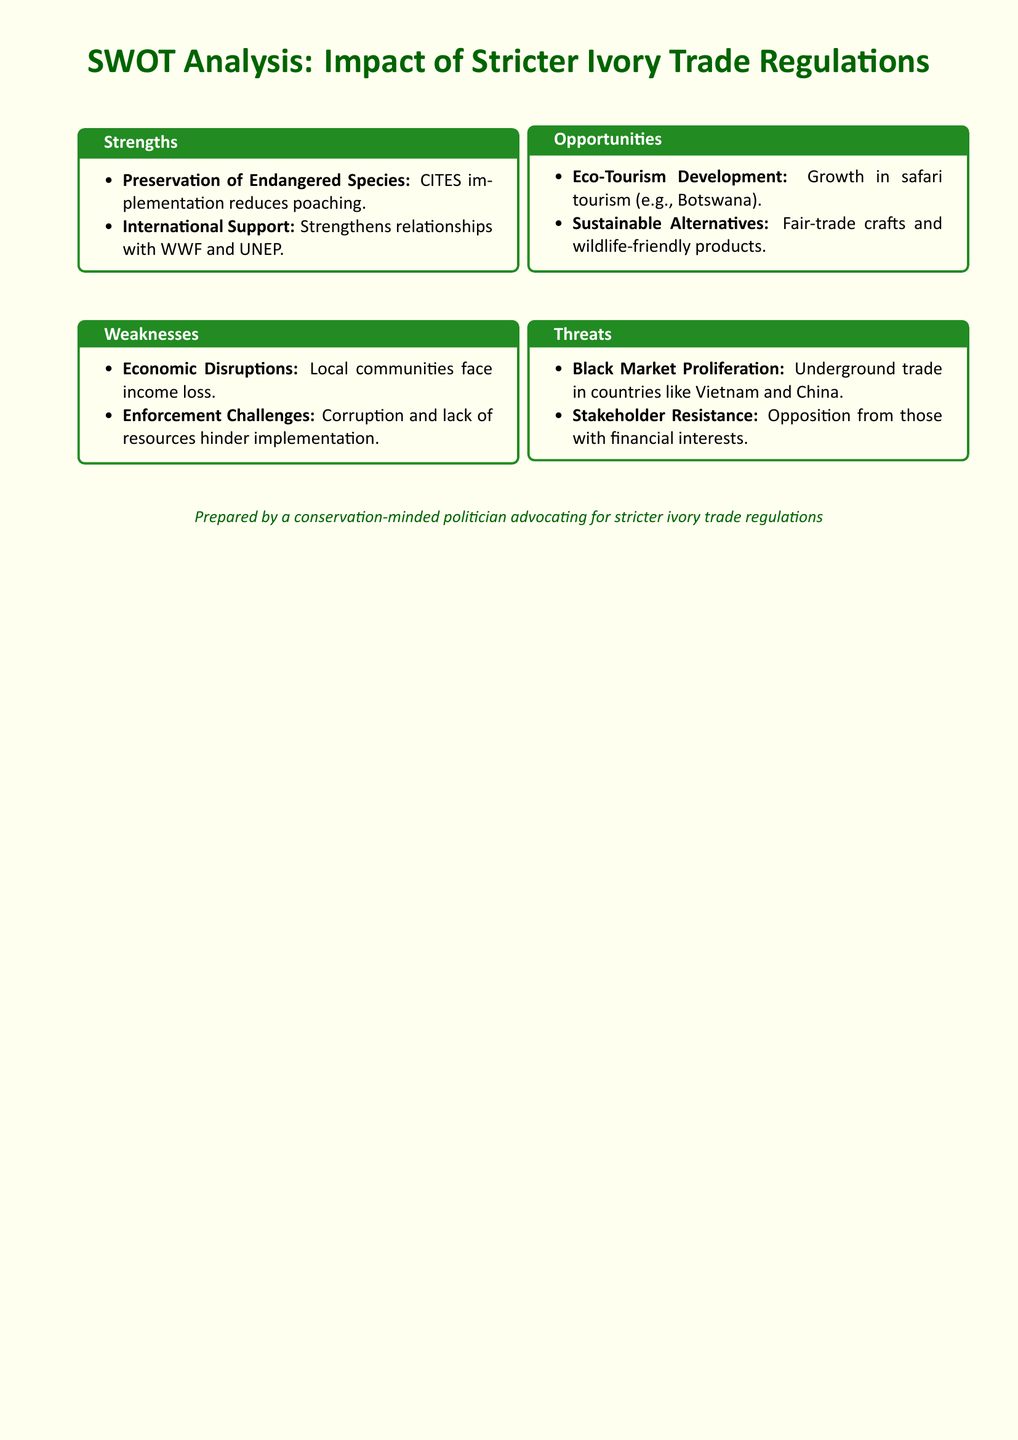What are the strengths related to elephant conservation? The strengths focus on the preservation of endangered species and international support from organizations like WWF and UNEP.
Answer: Preservation of Endangered Species, International Support What is a significant weakness of stricter ivory trade regulations? One major weakness identified is the potential economic disruptions that local communities may face due to income loss.
Answer: Economic Disruptions What opportunity is associated with the implementation of stricter regulations? The document highlights the potential for eco-tourism development as a crucial opportunity for local economies.
Answer: Eco-Tourism Development What does the threat of black market proliferation refer to? It refers to the illegal underground trade in ivory that could increase in countries such as Vietnam and China as a result of stricter regulations.
Answer: Black Market Proliferation How does the SWOT analysis categorize the impact of stricter regulations on local economies? The analysis categorizes the impact by identifying strengths, weaknesses, opportunities, and threats related to these regulations.
Answer: SWOT analysis What is a proposed sustainable alternative mentioned in the opportunities section? The document suggests the development of fair-trade crafts and wildlife-friendly products as an alternative.
Answer: Sustainable Alternatives 